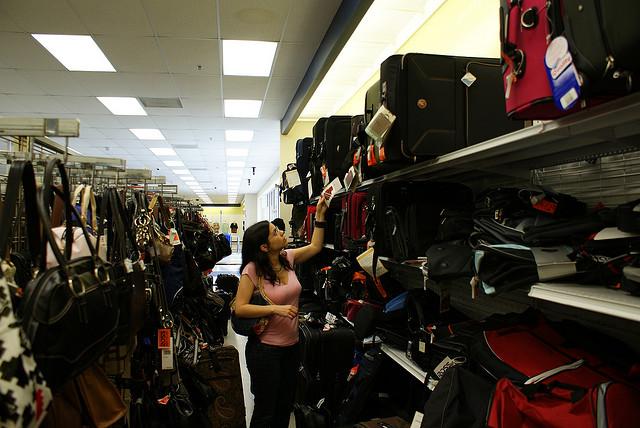What color is her shirt?
Write a very short answer. Pink. What objects are behind the shopper?
Be succinct. Purses. What is this woman shopping for?
Short answer required. Luggage. 